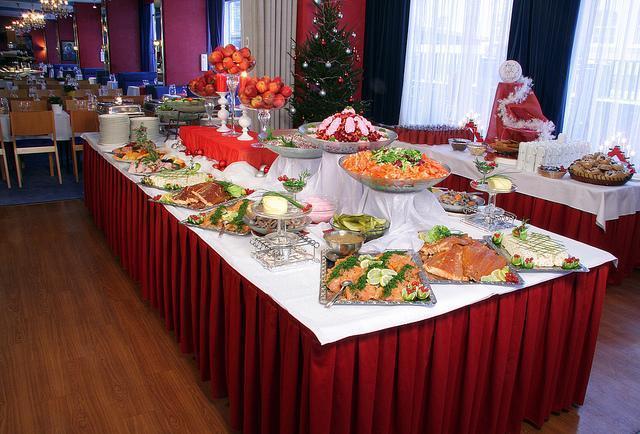How many dining tables are there?
Give a very brief answer. 2. How many bowls are there?
Give a very brief answer. 2. How many laptops are here?
Give a very brief answer. 0. 